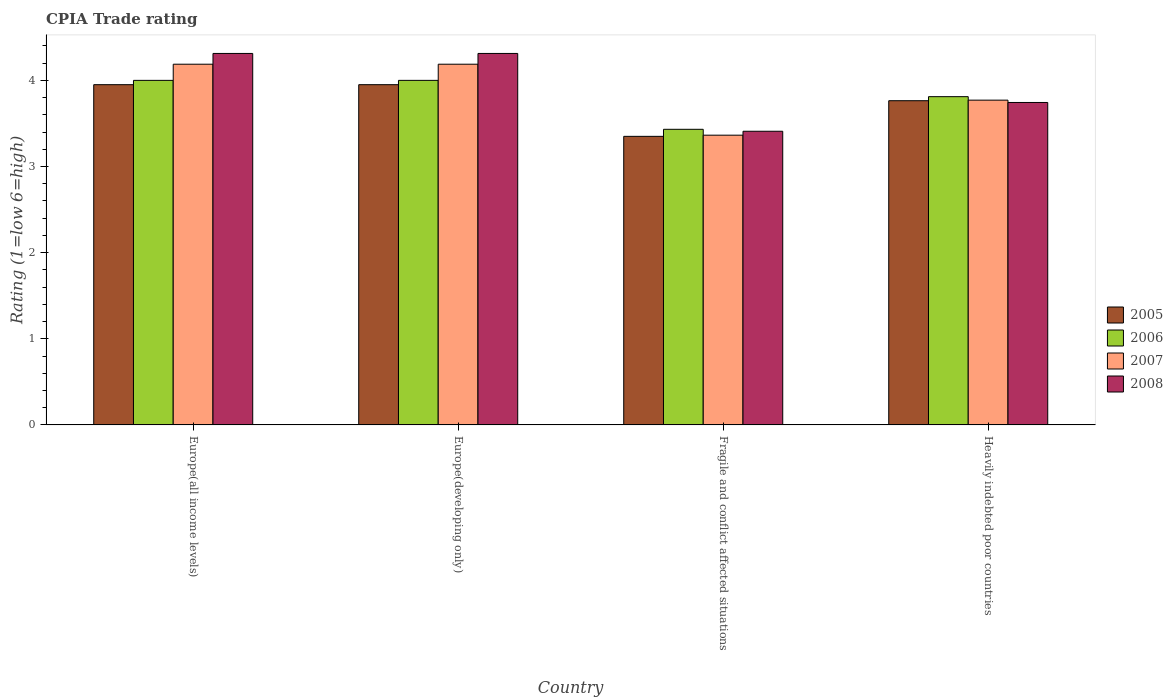How many different coloured bars are there?
Keep it short and to the point. 4. Are the number of bars on each tick of the X-axis equal?
Your answer should be compact. Yes. How many bars are there on the 4th tick from the right?
Make the answer very short. 4. What is the label of the 2nd group of bars from the left?
Offer a terse response. Europe(developing only). What is the CPIA rating in 2008 in Europe(all income levels)?
Your answer should be very brief. 4.31. Across all countries, what is the maximum CPIA rating in 2008?
Give a very brief answer. 4.31. Across all countries, what is the minimum CPIA rating in 2005?
Make the answer very short. 3.35. In which country was the CPIA rating in 2007 maximum?
Provide a short and direct response. Europe(all income levels). In which country was the CPIA rating in 2008 minimum?
Ensure brevity in your answer.  Fragile and conflict affected situations. What is the total CPIA rating in 2008 in the graph?
Your response must be concise. 15.78. What is the difference between the CPIA rating in 2008 in Fragile and conflict affected situations and the CPIA rating in 2007 in Europe(developing only)?
Your answer should be compact. -0.78. What is the average CPIA rating in 2008 per country?
Provide a succinct answer. 3.94. What is the difference between the CPIA rating of/in 2007 and CPIA rating of/in 2006 in Europe(all income levels)?
Your answer should be very brief. 0.19. In how many countries, is the CPIA rating in 2008 greater than 1.6?
Your answer should be compact. 4. What is the ratio of the CPIA rating in 2006 in Europe(developing only) to that in Fragile and conflict affected situations?
Your answer should be very brief. 1.17. Is the CPIA rating in 2006 in Europe(all income levels) less than that in Fragile and conflict affected situations?
Your answer should be very brief. No. What is the difference between the highest and the second highest CPIA rating in 2008?
Your answer should be compact. -0.57. What is the difference between the highest and the lowest CPIA rating in 2005?
Offer a very short reply. 0.6. In how many countries, is the CPIA rating in 2006 greater than the average CPIA rating in 2006 taken over all countries?
Offer a very short reply. 3. How many bars are there?
Keep it short and to the point. 16. How many countries are there in the graph?
Keep it short and to the point. 4. What is the difference between two consecutive major ticks on the Y-axis?
Your response must be concise. 1. Does the graph contain grids?
Ensure brevity in your answer.  No. How many legend labels are there?
Ensure brevity in your answer.  4. What is the title of the graph?
Your answer should be compact. CPIA Trade rating. Does "1979" appear as one of the legend labels in the graph?
Offer a very short reply. No. What is the label or title of the Y-axis?
Ensure brevity in your answer.  Rating (1=low 6=high). What is the Rating (1=low 6=high) in 2005 in Europe(all income levels)?
Your answer should be very brief. 3.95. What is the Rating (1=low 6=high) in 2006 in Europe(all income levels)?
Ensure brevity in your answer.  4. What is the Rating (1=low 6=high) of 2007 in Europe(all income levels)?
Provide a succinct answer. 4.19. What is the Rating (1=low 6=high) of 2008 in Europe(all income levels)?
Provide a short and direct response. 4.31. What is the Rating (1=low 6=high) of 2005 in Europe(developing only)?
Offer a terse response. 3.95. What is the Rating (1=low 6=high) of 2006 in Europe(developing only)?
Offer a very short reply. 4. What is the Rating (1=low 6=high) in 2007 in Europe(developing only)?
Your answer should be compact. 4.19. What is the Rating (1=low 6=high) of 2008 in Europe(developing only)?
Ensure brevity in your answer.  4.31. What is the Rating (1=low 6=high) in 2005 in Fragile and conflict affected situations?
Provide a succinct answer. 3.35. What is the Rating (1=low 6=high) in 2006 in Fragile and conflict affected situations?
Provide a short and direct response. 3.43. What is the Rating (1=low 6=high) of 2007 in Fragile and conflict affected situations?
Give a very brief answer. 3.36. What is the Rating (1=low 6=high) of 2008 in Fragile and conflict affected situations?
Your answer should be compact. 3.41. What is the Rating (1=low 6=high) of 2005 in Heavily indebted poor countries?
Your response must be concise. 3.76. What is the Rating (1=low 6=high) in 2006 in Heavily indebted poor countries?
Offer a terse response. 3.81. What is the Rating (1=low 6=high) in 2007 in Heavily indebted poor countries?
Provide a succinct answer. 3.77. What is the Rating (1=low 6=high) in 2008 in Heavily indebted poor countries?
Offer a terse response. 3.74. Across all countries, what is the maximum Rating (1=low 6=high) of 2005?
Keep it short and to the point. 3.95. Across all countries, what is the maximum Rating (1=low 6=high) in 2007?
Your answer should be compact. 4.19. Across all countries, what is the maximum Rating (1=low 6=high) of 2008?
Make the answer very short. 4.31. Across all countries, what is the minimum Rating (1=low 6=high) of 2005?
Your answer should be compact. 3.35. Across all countries, what is the minimum Rating (1=low 6=high) in 2006?
Give a very brief answer. 3.43. Across all countries, what is the minimum Rating (1=low 6=high) of 2007?
Your answer should be compact. 3.36. Across all countries, what is the minimum Rating (1=low 6=high) of 2008?
Offer a terse response. 3.41. What is the total Rating (1=low 6=high) of 2005 in the graph?
Provide a succinct answer. 15.01. What is the total Rating (1=low 6=high) of 2006 in the graph?
Your response must be concise. 15.24. What is the total Rating (1=low 6=high) of 2007 in the graph?
Make the answer very short. 15.51. What is the total Rating (1=low 6=high) in 2008 in the graph?
Your answer should be compact. 15.78. What is the difference between the Rating (1=low 6=high) of 2005 in Europe(all income levels) and that in Europe(developing only)?
Give a very brief answer. 0. What is the difference between the Rating (1=low 6=high) in 2006 in Europe(all income levels) and that in Europe(developing only)?
Offer a very short reply. 0. What is the difference between the Rating (1=low 6=high) in 2007 in Europe(all income levels) and that in Europe(developing only)?
Ensure brevity in your answer.  0. What is the difference between the Rating (1=low 6=high) in 2005 in Europe(all income levels) and that in Fragile and conflict affected situations?
Your response must be concise. 0.6. What is the difference between the Rating (1=low 6=high) in 2006 in Europe(all income levels) and that in Fragile and conflict affected situations?
Make the answer very short. 0.57. What is the difference between the Rating (1=low 6=high) in 2007 in Europe(all income levels) and that in Fragile and conflict affected situations?
Give a very brief answer. 0.82. What is the difference between the Rating (1=low 6=high) in 2008 in Europe(all income levels) and that in Fragile and conflict affected situations?
Give a very brief answer. 0.9. What is the difference between the Rating (1=low 6=high) of 2005 in Europe(all income levels) and that in Heavily indebted poor countries?
Provide a succinct answer. 0.19. What is the difference between the Rating (1=low 6=high) of 2006 in Europe(all income levels) and that in Heavily indebted poor countries?
Ensure brevity in your answer.  0.19. What is the difference between the Rating (1=low 6=high) of 2007 in Europe(all income levels) and that in Heavily indebted poor countries?
Offer a terse response. 0.42. What is the difference between the Rating (1=low 6=high) in 2008 in Europe(all income levels) and that in Heavily indebted poor countries?
Offer a terse response. 0.57. What is the difference between the Rating (1=low 6=high) of 2005 in Europe(developing only) and that in Fragile and conflict affected situations?
Your answer should be very brief. 0.6. What is the difference between the Rating (1=low 6=high) of 2006 in Europe(developing only) and that in Fragile and conflict affected situations?
Your answer should be very brief. 0.57. What is the difference between the Rating (1=low 6=high) of 2007 in Europe(developing only) and that in Fragile and conflict affected situations?
Provide a short and direct response. 0.82. What is the difference between the Rating (1=low 6=high) in 2008 in Europe(developing only) and that in Fragile and conflict affected situations?
Your answer should be compact. 0.9. What is the difference between the Rating (1=low 6=high) in 2005 in Europe(developing only) and that in Heavily indebted poor countries?
Offer a terse response. 0.19. What is the difference between the Rating (1=low 6=high) of 2006 in Europe(developing only) and that in Heavily indebted poor countries?
Your response must be concise. 0.19. What is the difference between the Rating (1=low 6=high) in 2007 in Europe(developing only) and that in Heavily indebted poor countries?
Give a very brief answer. 0.42. What is the difference between the Rating (1=low 6=high) of 2008 in Europe(developing only) and that in Heavily indebted poor countries?
Offer a terse response. 0.57. What is the difference between the Rating (1=low 6=high) in 2005 in Fragile and conflict affected situations and that in Heavily indebted poor countries?
Offer a very short reply. -0.41. What is the difference between the Rating (1=low 6=high) in 2006 in Fragile and conflict affected situations and that in Heavily indebted poor countries?
Your answer should be compact. -0.38. What is the difference between the Rating (1=low 6=high) in 2007 in Fragile and conflict affected situations and that in Heavily indebted poor countries?
Keep it short and to the point. -0.41. What is the difference between the Rating (1=low 6=high) of 2008 in Fragile and conflict affected situations and that in Heavily indebted poor countries?
Give a very brief answer. -0.33. What is the difference between the Rating (1=low 6=high) in 2005 in Europe(all income levels) and the Rating (1=low 6=high) in 2006 in Europe(developing only)?
Offer a terse response. -0.05. What is the difference between the Rating (1=low 6=high) in 2005 in Europe(all income levels) and the Rating (1=low 6=high) in 2007 in Europe(developing only)?
Offer a terse response. -0.24. What is the difference between the Rating (1=low 6=high) in 2005 in Europe(all income levels) and the Rating (1=low 6=high) in 2008 in Europe(developing only)?
Offer a terse response. -0.36. What is the difference between the Rating (1=low 6=high) in 2006 in Europe(all income levels) and the Rating (1=low 6=high) in 2007 in Europe(developing only)?
Your answer should be compact. -0.19. What is the difference between the Rating (1=low 6=high) of 2006 in Europe(all income levels) and the Rating (1=low 6=high) of 2008 in Europe(developing only)?
Provide a short and direct response. -0.31. What is the difference between the Rating (1=low 6=high) of 2007 in Europe(all income levels) and the Rating (1=low 6=high) of 2008 in Europe(developing only)?
Offer a terse response. -0.12. What is the difference between the Rating (1=low 6=high) of 2005 in Europe(all income levels) and the Rating (1=low 6=high) of 2006 in Fragile and conflict affected situations?
Offer a very short reply. 0.52. What is the difference between the Rating (1=low 6=high) of 2005 in Europe(all income levels) and the Rating (1=low 6=high) of 2007 in Fragile and conflict affected situations?
Offer a very short reply. 0.59. What is the difference between the Rating (1=low 6=high) of 2005 in Europe(all income levels) and the Rating (1=low 6=high) of 2008 in Fragile and conflict affected situations?
Your answer should be very brief. 0.54. What is the difference between the Rating (1=low 6=high) of 2006 in Europe(all income levels) and the Rating (1=low 6=high) of 2007 in Fragile and conflict affected situations?
Offer a very short reply. 0.64. What is the difference between the Rating (1=low 6=high) of 2006 in Europe(all income levels) and the Rating (1=low 6=high) of 2008 in Fragile and conflict affected situations?
Make the answer very short. 0.59. What is the difference between the Rating (1=low 6=high) of 2007 in Europe(all income levels) and the Rating (1=low 6=high) of 2008 in Fragile and conflict affected situations?
Offer a very short reply. 0.78. What is the difference between the Rating (1=low 6=high) in 2005 in Europe(all income levels) and the Rating (1=low 6=high) in 2006 in Heavily indebted poor countries?
Your response must be concise. 0.14. What is the difference between the Rating (1=low 6=high) in 2005 in Europe(all income levels) and the Rating (1=low 6=high) in 2007 in Heavily indebted poor countries?
Keep it short and to the point. 0.18. What is the difference between the Rating (1=low 6=high) in 2005 in Europe(all income levels) and the Rating (1=low 6=high) in 2008 in Heavily indebted poor countries?
Give a very brief answer. 0.21. What is the difference between the Rating (1=low 6=high) in 2006 in Europe(all income levels) and the Rating (1=low 6=high) in 2007 in Heavily indebted poor countries?
Ensure brevity in your answer.  0.23. What is the difference between the Rating (1=low 6=high) in 2006 in Europe(all income levels) and the Rating (1=low 6=high) in 2008 in Heavily indebted poor countries?
Your answer should be very brief. 0.26. What is the difference between the Rating (1=low 6=high) of 2007 in Europe(all income levels) and the Rating (1=low 6=high) of 2008 in Heavily indebted poor countries?
Ensure brevity in your answer.  0.44. What is the difference between the Rating (1=low 6=high) of 2005 in Europe(developing only) and the Rating (1=low 6=high) of 2006 in Fragile and conflict affected situations?
Provide a succinct answer. 0.52. What is the difference between the Rating (1=low 6=high) in 2005 in Europe(developing only) and the Rating (1=low 6=high) in 2007 in Fragile and conflict affected situations?
Offer a terse response. 0.59. What is the difference between the Rating (1=low 6=high) in 2005 in Europe(developing only) and the Rating (1=low 6=high) in 2008 in Fragile and conflict affected situations?
Your answer should be compact. 0.54. What is the difference between the Rating (1=low 6=high) of 2006 in Europe(developing only) and the Rating (1=low 6=high) of 2007 in Fragile and conflict affected situations?
Your response must be concise. 0.64. What is the difference between the Rating (1=low 6=high) in 2006 in Europe(developing only) and the Rating (1=low 6=high) in 2008 in Fragile and conflict affected situations?
Give a very brief answer. 0.59. What is the difference between the Rating (1=low 6=high) of 2007 in Europe(developing only) and the Rating (1=low 6=high) of 2008 in Fragile and conflict affected situations?
Provide a short and direct response. 0.78. What is the difference between the Rating (1=low 6=high) in 2005 in Europe(developing only) and the Rating (1=low 6=high) in 2006 in Heavily indebted poor countries?
Provide a succinct answer. 0.14. What is the difference between the Rating (1=low 6=high) of 2005 in Europe(developing only) and the Rating (1=low 6=high) of 2007 in Heavily indebted poor countries?
Make the answer very short. 0.18. What is the difference between the Rating (1=low 6=high) in 2005 in Europe(developing only) and the Rating (1=low 6=high) in 2008 in Heavily indebted poor countries?
Your response must be concise. 0.21. What is the difference between the Rating (1=low 6=high) in 2006 in Europe(developing only) and the Rating (1=low 6=high) in 2007 in Heavily indebted poor countries?
Offer a very short reply. 0.23. What is the difference between the Rating (1=low 6=high) in 2006 in Europe(developing only) and the Rating (1=low 6=high) in 2008 in Heavily indebted poor countries?
Ensure brevity in your answer.  0.26. What is the difference between the Rating (1=low 6=high) in 2007 in Europe(developing only) and the Rating (1=low 6=high) in 2008 in Heavily indebted poor countries?
Offer a very short reply. 0.44. What is the difference between the Rating (1=low 6=high) of 2005 in Fragile and conflict affected situations and the Rating (1=low 6=high) of 2006 in Heavily indebted poor countries?
Make the answer very short. -0.46. What is the difference between the Rating (1=low 6=high) of 2005 in Fragile and conflict affected situations and the Rating (1=low 6=high) of 2007 in Heavily indebted poor countries?
Your answer should be compact. -0.42. What is the difference between the Rating (1=low 6=high) in 2005 in Fragile and conflict affected situations and the Rating (1=low 6=high) in 2008 in Heavily indebted poor countries?
Your answer should be compact. -0.39. What is the difference between the Rating (1=low 6=high) of 2006 in Fragile and conflict affected situations and the Rating (1=low 6=high) of 2007 in Heavily indebted poor countries?
Offer a terse response. -0.34. What is the difference between the Rating (1=low 6=high) of 2006 in Fragile and conflict affected situations and the Rating (1=low 6=high) of 2008 in Heavily indebted poor countries?
Keep it short and to the point. -0.31. What is the difference between the Rating (1=low 6=high) in 2007 in Fragile and conflict affected situations and the Rating (1=low 6=high) in 2008 in Heavily indebted poor countries?
Keep it short and to the point. -0.38. What is the average Rating (1=low 6=high) in 2005 per country?
Ensure brevity in your answer.  3.75. What is the average Rating (1=low 6=high) in 2006 per country?
Provide a short and direct response. 3.81. What is the average Rating (1=low 6=high) in 2007 per country?
Make the answer very short. 3.88. What is the average Rating (1=low 6=high) of 2008 per country?
Provide a succinct answer. 3.94. What is the difference between the Rating (1=low 6=high) of 2005 and Rating (1=low 6=high) of 2006 in Europe(all income levels)?
Offer a terse response. -0.05. What is the difference between the Rating (1=low 6=high) of 2005 and Rating (1=low 6=high) of 2007 in Europe(all income levels)?
Your answer should be compact. -0.24. What is the difference between the Rating (1=low 6=high) in 2005 and Rating (1=low 6=high) in 2008 in Europe(all income levels)?
Your answer should be compact. -0.36. What is the difference between the Rating (1=low 6=high) of 2006 and Rating (1=low 6=high) of 2007 in Europe(all income levels)?
Provide a succinct answer. -0.19. What is the difference between the Rating (1=low 6=high) in 2006 and Rating (1=low 6=high) in 2008 in Europe(all income levels)?
Provide a short and direct response. -0.31. What is the difference between the Rating (1=low 6=high) in 2007 and Rating (1=low 6=high) in 2008 in Europe(all income levels)?
Provide a succinct answer. -0.12. What is the difference between the Rating (1=low 6=high) of 2005 and Rating (1=low 6=high) of 2006 in Europe(developing only)?
Offer a very short reply. -0.05. What is the difference between the Rating (1=low 6=high) of 2005 and Rating (1=low 6=high) of 2007 in Europe(developing only)?
Ensure brevity in your answer.  -0.24. What is the difference between the Rating (1=low 6=high) in 2005 and Rating (1=low 6=high) in 2008 in Europe(developing only)?
Make the answer very short. -0.36. What is the difference between the Rating (1=low 6=high) in 2006 and Rating (1=low 6=high) in 2007 in Europe(developing only)?
Offer a terse response. -0.19. What is the difference between the Rating (1=low 6=high) in 2006 and Rating (1=low 6=high) in 2008 in Europe(developing only)?
Ensure brevity in your answer.  -0.31. What is the difference between the Rating (1=low 6=high) in 2007 and Rating (1=low 6=high) in 2008 in Europe(developing only)?
Your response must be concise. -0.12. What is the difference between the Rating (1=low 6=high) in 2005 and Rating (1=low 6=high) in 2006 in Fragile and conflict affected situations?
Ensure brevity in your answer.  -0.08. What is the difference between the Rating (1=low 6=high) in 2005 and Rating (1=low 6=high) in 2007 in Fragile and conflict affected situations?
Make the answer very short. -0.01. What is the difference between the Rating (1=low 6=high) in 2005 and Rating (1=low 6=high) in 2008 in Fragile and conflict affected situations?
Your answer should be very brief. -0.06. What is the difference between the Rating (1=low 6=high) in 2006 and Rating (1=low 6=high) in 2007 in Fragile and conflict affected situations?
Make the answer very short. 0.07. What is the difference between the Rating (1=low 6=high) of 2006 and Rating (1=low 6=high) of 2008 in Fragile and conflict affected situations?
Make the answer very short. 0.02. What is the difference between the Rating (1=low 6=high) in 2007 and Rating (1=low 6=high) in 2008 in Fragile and conflict affected situations?
Provide a succinct answer. -0.05. What is the difference between the Rating (1=low 6=high) in 2005 and Rating (1=low 6=high) in 2006 in Heavily indebted poor countries?
Give a very brief answer. -0.05. What is the difference between the Rating (1=low 6=high) of 2005 and Rating (1=low 6=high) of 2007 in Heavily indebted poor countries?
Your response must be concise. -0.01. What is the difference between the Rating (1=low 6=high) in 2005 and Rating (1=low 6=high) in 2008 in Heavily indebted poor countries?
Give a very brief answer. 0.02. What is the difference between the Rating (1=low 6=high) in 2006 and Rating (1=low 6=high) in 2007 in Heavily indebted poor countries?
Provide a short and direct response. 0.04. What is the difference between the Rating (1=low 6=high) of 2006 and Rating (1=low 6=high) of 2008 in Heavily indebted poor countries?
Keep it short and to the point. 0.07. What is the difference between the Rating (1=low 6=high) in 2007 and Rating (1=low 6=high) in 2008 in Heavily indebted poor countries?
Provide a succinct answer. 0.03. What is the ratio of the Rating (1=low 6=high) in 2005 in Europe(all income levels) to that in Fragile and conflict affected situations?
Your answer should be compact. 1.18. What is the ratio of the Rating (1=low 6=high) of 2006 in Europe(all income levels) to that in Fragile and conflict affected situations?
Make the answer very short. 1.17. What is the ratio of the Rating (1=low 6=high) in 2007 in Europe(all income levels) to that in Fragile and conflict affected situations?
Offer a very short reply. 1.24. What is the ratio of the Rating (1=low 6=high) of 2008 in Europe(all income levels) to that in Fragile and conflict affected situations?
Your answer should be compact. 1.26. What is the ratio of the Rating (1=low 6=high) in 2005 in Europe(all income levels) to that in Heavily indebted poor countries?
Your response must be concise. 1.05. What is the ratio of the Rating (1=low 6=high) of 2006 in Europe(all income levels) to that in Heavily indebted poor countries?
Make the answer very short. 1.05. What is the ratio of the Rating (1=low 6=high) in 2007 in Europe(all income levels) to that in Heavily indebted poor countries?
Your answer should be compact. 1.11. What is the ratio of the Rating (1=low 6=high) in 2008 in Europe(all income levels) to that in Heavily indebted poor countries?
Offer a very short reply. 1.15. What is the ratio of the Rating (1=low 6=high) of 2005 in Europe(developing only) to that in Fragile and conflict affected situations?
Provide a short and direct response. 1.18. What is the ratio of the Rating (1=low 6=high) in 2006 in Europe(developing only) to that in Fragile and conflict affected situations?
Offer a terse response. 1.17. What is the ratio of the Rating (1=low 6=high) of 2007 in Europe(developing only) to that in Fragile and conflict affected situations?
Your answer should be compact. 1.24. What is the ratio of the Rating (1=low 6=high) of 2008 in Europe(developing only) to that in Fragile and conflict affected situations?
Give a very brief answer. 1.26. What is the ratio of the Rating (1=low 6=high) of 2005 in Europe(developing only) to that in Heavily indebted poor countries?
Offer a terse response. 1.05. What is the ratio of the Rating (1=low 6=high) of 2006 in Europe(developing only) to that in Heavily indebted poor countries?
Provide a short and direct response. 1.05. What is the ratio of the Rating (1=low 6=high) in 2007 in Europe(developing only) to that in Heavily indebted poor countries?
Offer a terse response. 1.11. What is the ratio of the Rating (1=low 6=high) in 2008 in Europe(developing only) to that in Heavily indebted poor countries?
Give a very brief answer. 1.15. What is the ratio of the Rating (1=low 6=high) in 2005 in Fragile and conflict affected situations to that in Heavily indebted poor countries?
Provide a short and direct response. 0.89. What is the ratio of the Rating (1=low 6=high) of 2006 in Fragile and conflict affected situations to that in Heavily indebted poor countries?
Your answer should be very brief. 0.9. What is the ratio of the Rating (1=low 6=high) in 2007 in Fragile and conflict affected situations to that in Heavily indebted poor countries?
Keep it short and to the point. 0.89. What is the ratio of the Rating (1=low 6=high) in 2008 in Fragile and conflict affected situations to that in Heavily indebted poor countries?
Your response must be concise. 0.91. What is the difference between the highest and the second highest Rating (1=low 6=high) of 2006?
Your answer should be very brief. 0. What is the difference between the highest and the second highest Rating (1=low 6=high) in 2007?
Your answer should be very brief. 0. What is the difference between the highest and the lowest Rating (1=low 6=high) of 2006?
Provide a succinct answer. 0.57. What is the difference between the highest and the lowest Rating (1=low 6=high) of 2007?
Your answer should be very brief. 0.82. What is the difference between the highest and the lowest Rating (1=low 6=high) in 2008?
Provide a succinct answer. 0.9. 